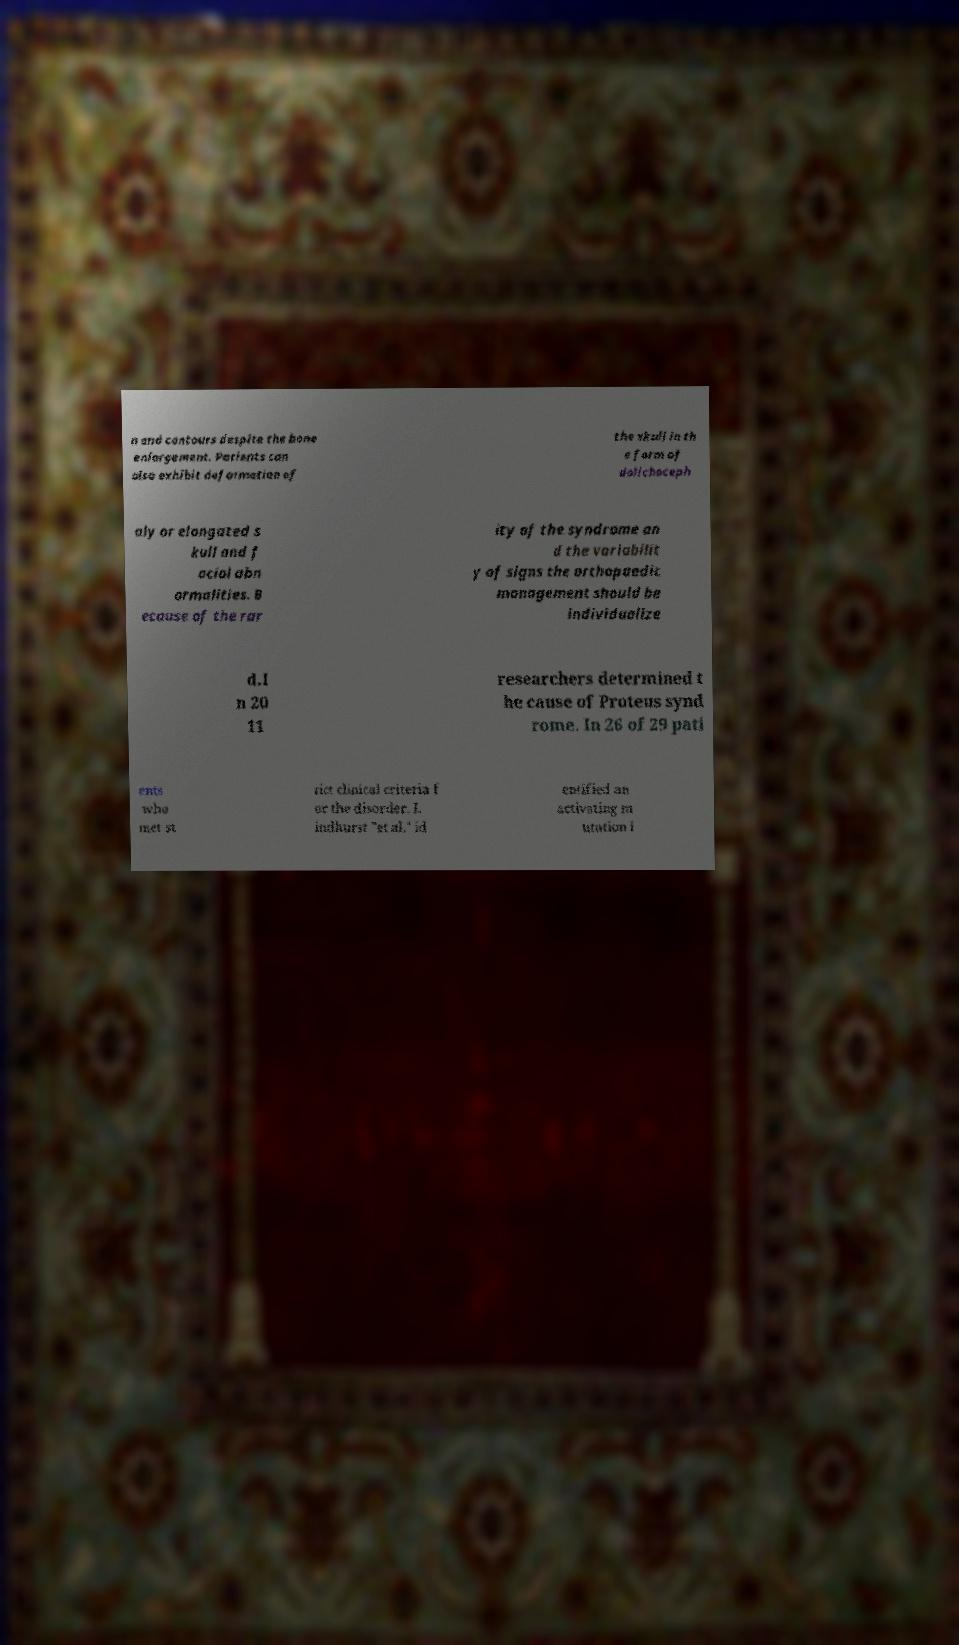Could you extract and type out the text from this image? n and contours despite the bone enlargement. Patients can also exhibit deformation of the skull in th e form of dolichoceph aly or elongated s kull and f acial abn ormalities. B ecause of the rar ity of the syndrome an d the variabilit y of signs the orthopaedic management should be individualize d.I n 20 11 researchers determined t he cause of Proteus synd rome. In 26 of 29 pati ents who met st rict clinical criteria f or the disorder, L indhurst "et al." id entified an activating m utation i 